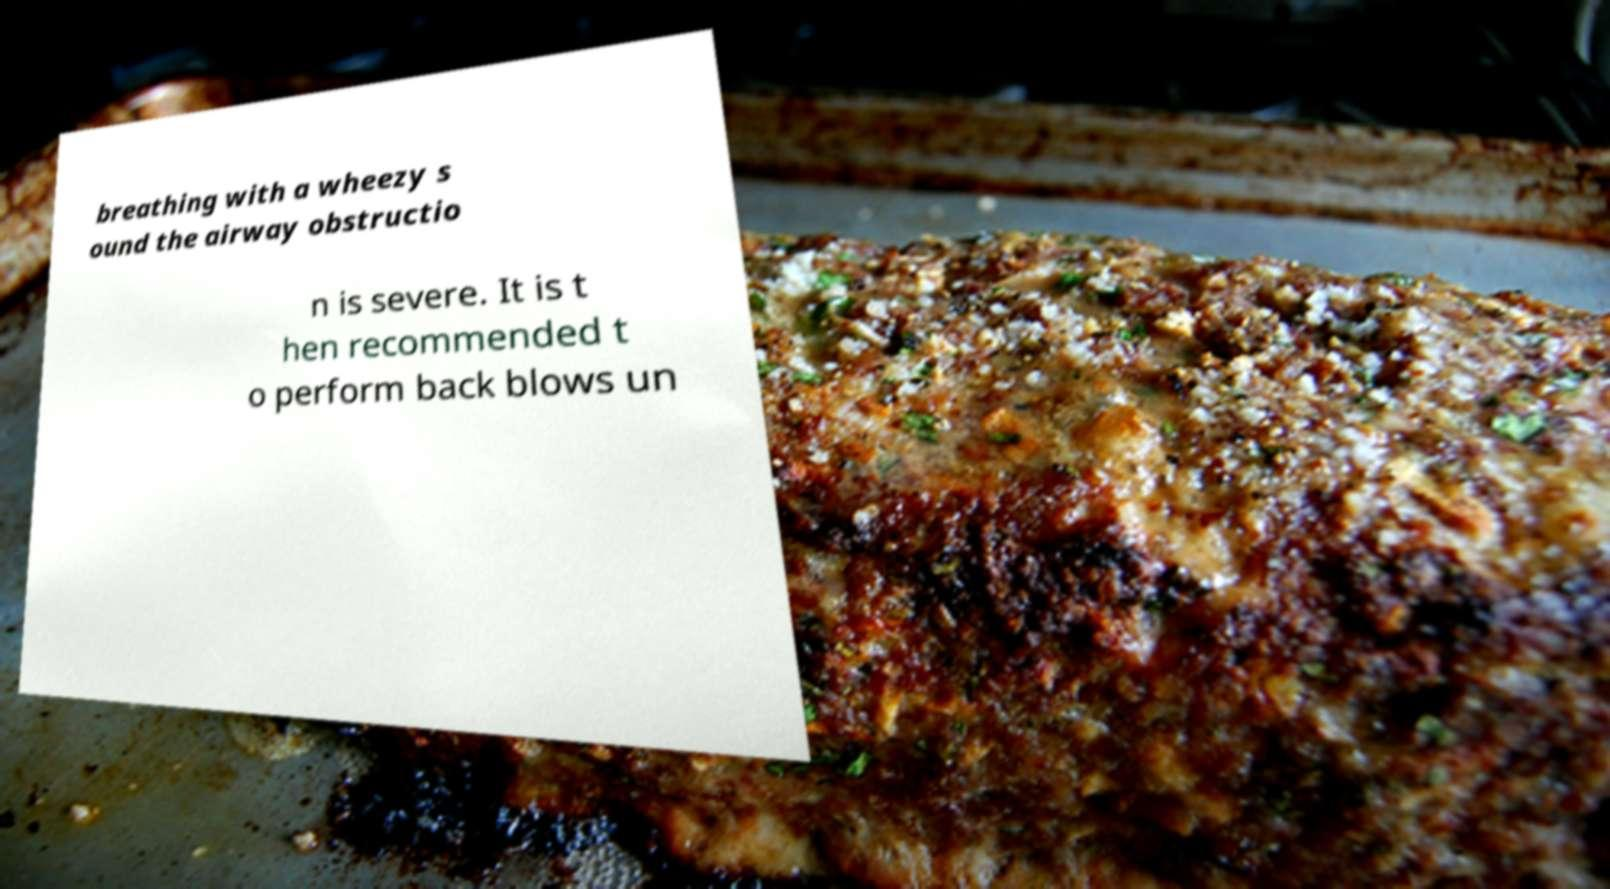For documentation purposes, I need the text within this image transcribed. Could you provide that? breathing with a wheezy s ound the airway obstructio n is severe. It is t hen recommended t o perform back blows un 